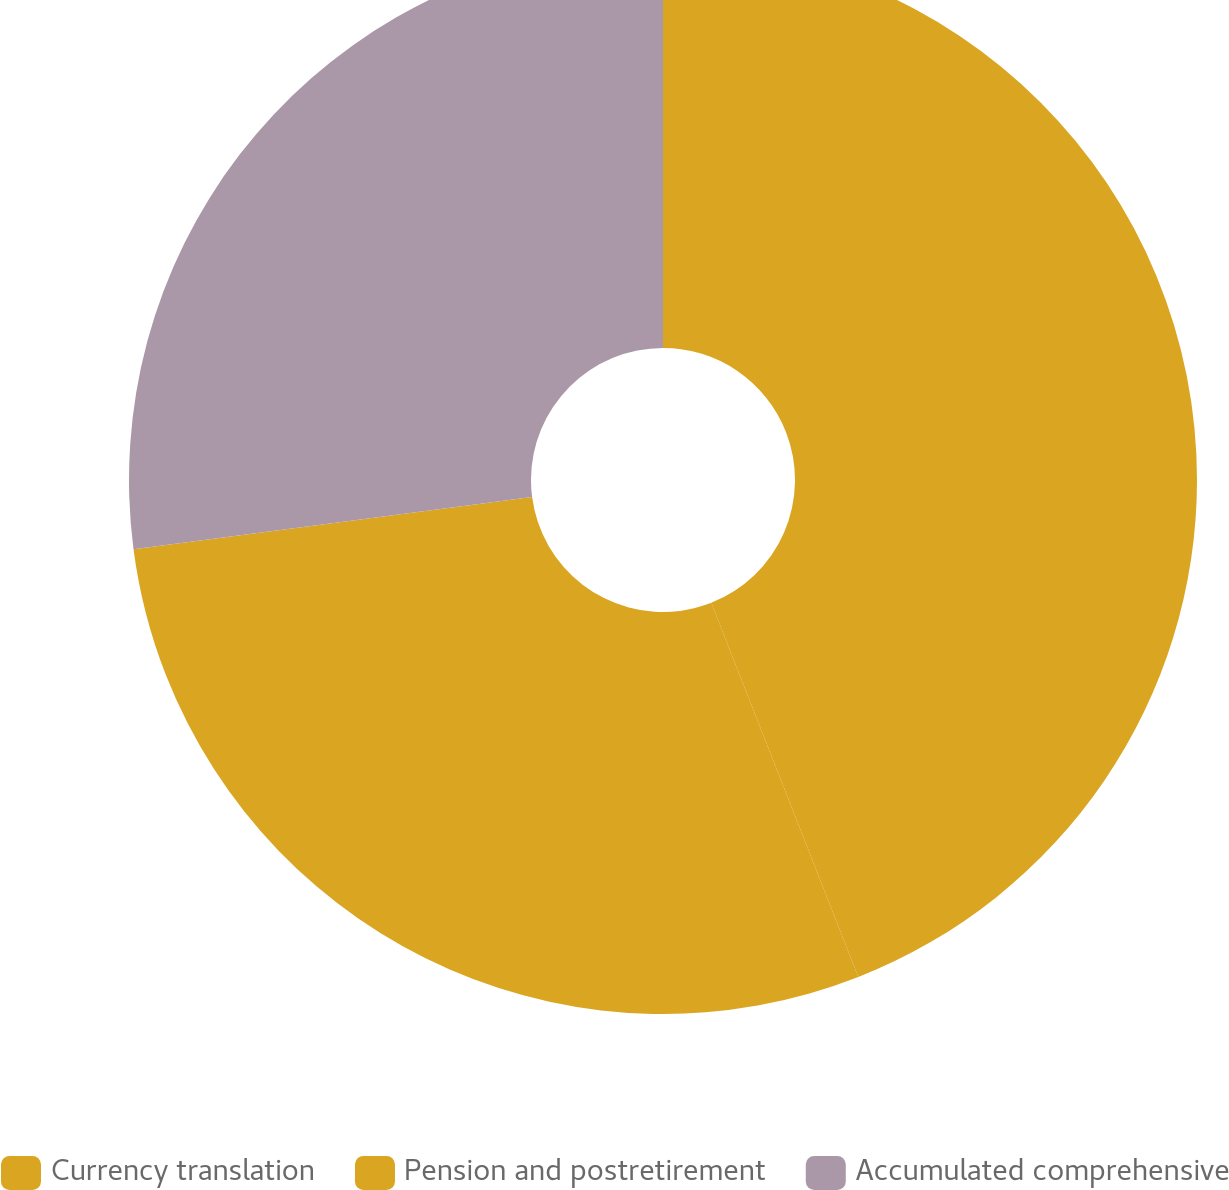<chart> <loc_0><loc_0><loc_500><loc_500><pie_chart><fcel>Currency translation<fcel>Pension and postretirement<fcel>Accumulated comprehensive<nl><fcel>44.04%<fcel>28.89%<fcel>27.07%<nl></chart> 